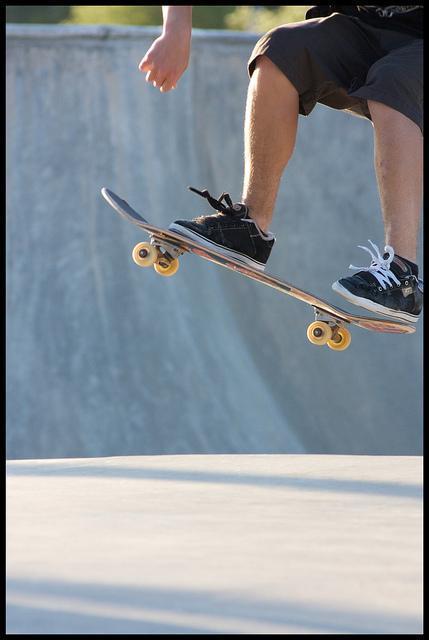How many skateboards are there?
Give a very brief answer. 1. 